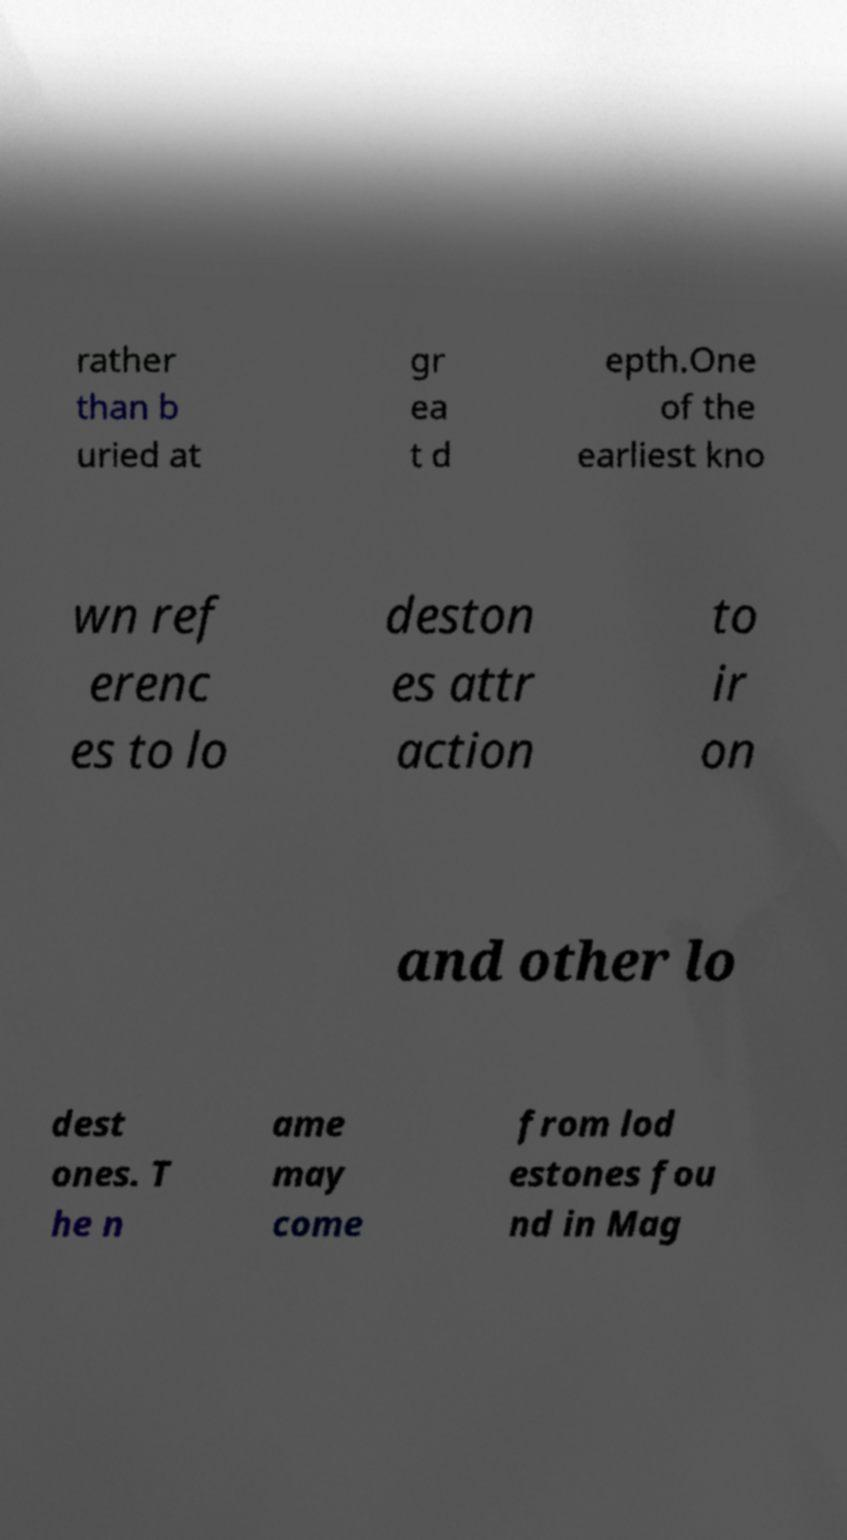Please read and relay the text visible in this image. What does it say? rather than b uried at gr ea t d epth.One of the earliest kno wn ref erenc es to lo deston es attr action to ir on and other lo dest ones. T he n ame may come from lod estones fou nd in Mag 